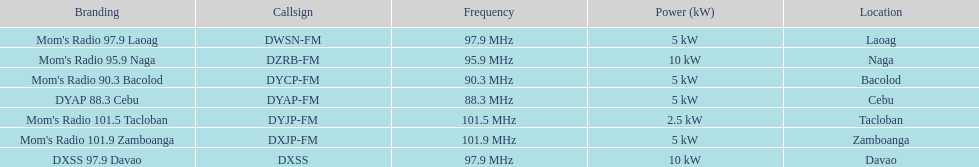How many stations broadcast with a power of 5kw? 4. 